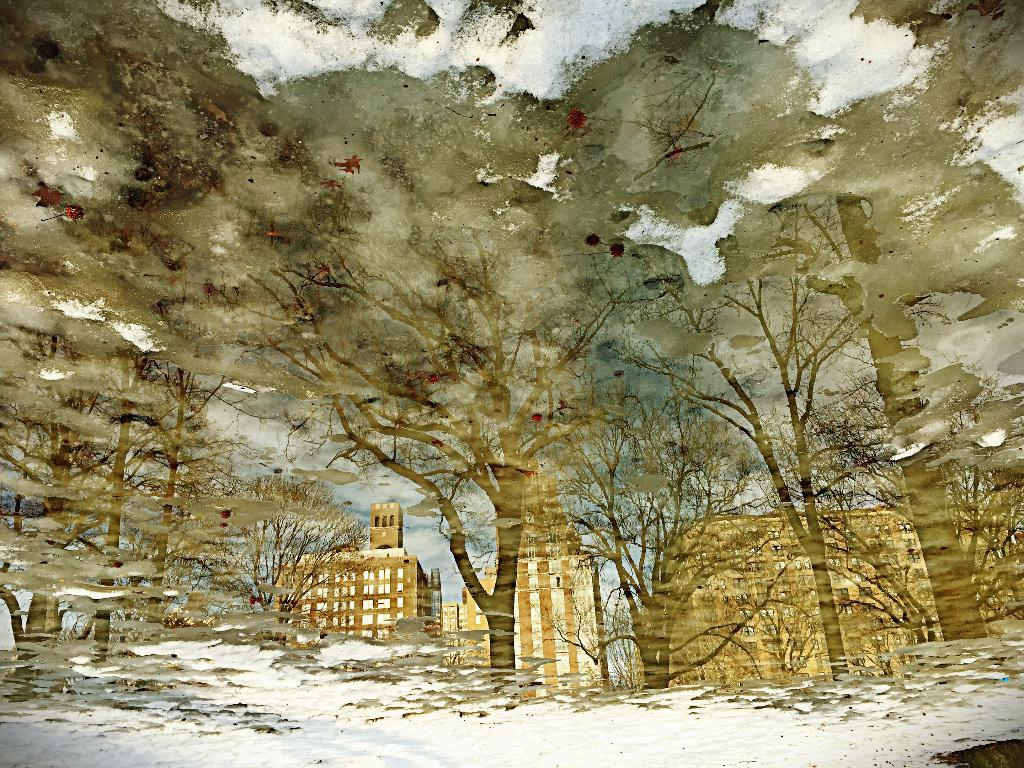What type of artwork is depicted in the image? The image is a painting. What structures can be seen in the painting? There are images of buildings in the painting. What type of vegetation is present in the painting? There are trees with stems, branches, and leaves in the painting. How many pigs can be seen grazing in the cellar of the building in the painting? There are no pigs present in the painting, nor is there a cellar depicted. 